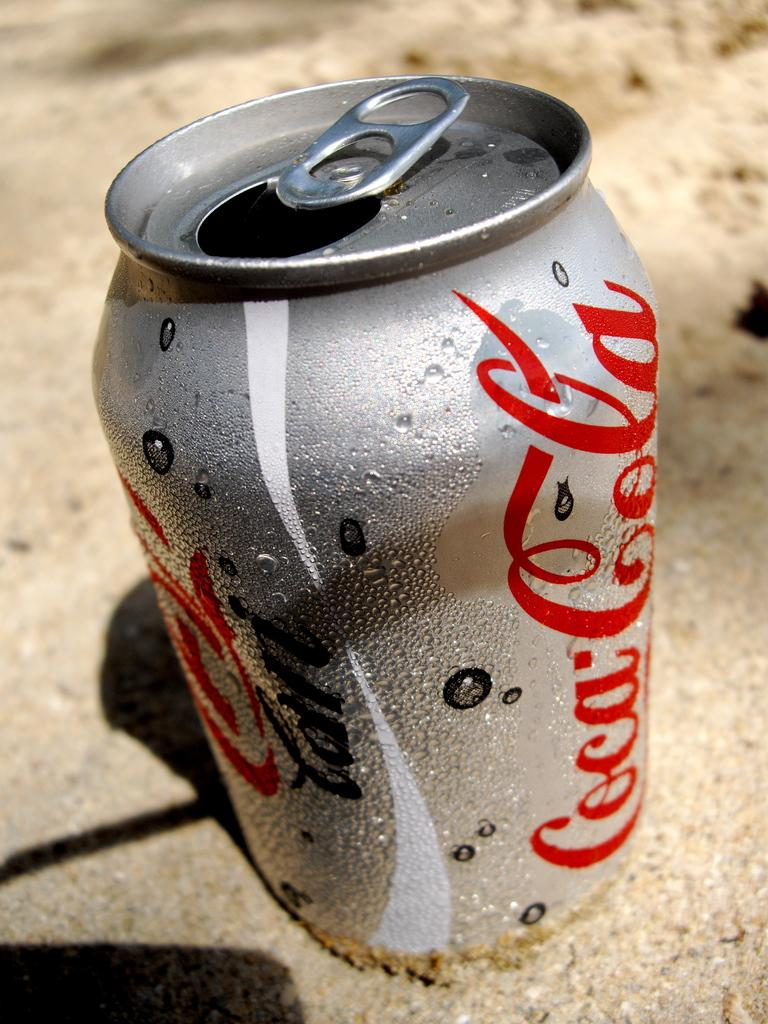<image>
Relay a brief, clear account of the picture shown. A can of diet Coca-cola is sitting on the sand. 